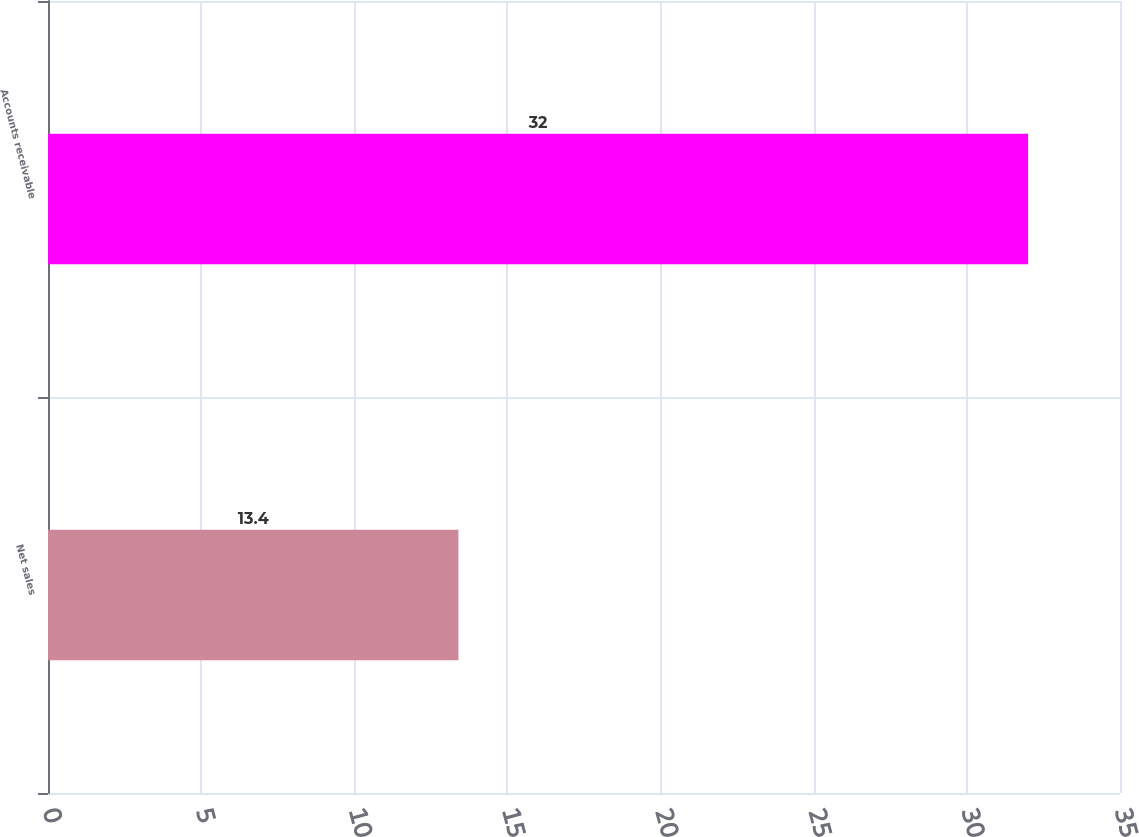Convert chart. <chart><loc_0><loc_0><loc_500><loc_500><bar_chart><fcel>Net sales<fcel>Accounts receivable<nl><fcel>13.4<fcel>32<nl></chart> 